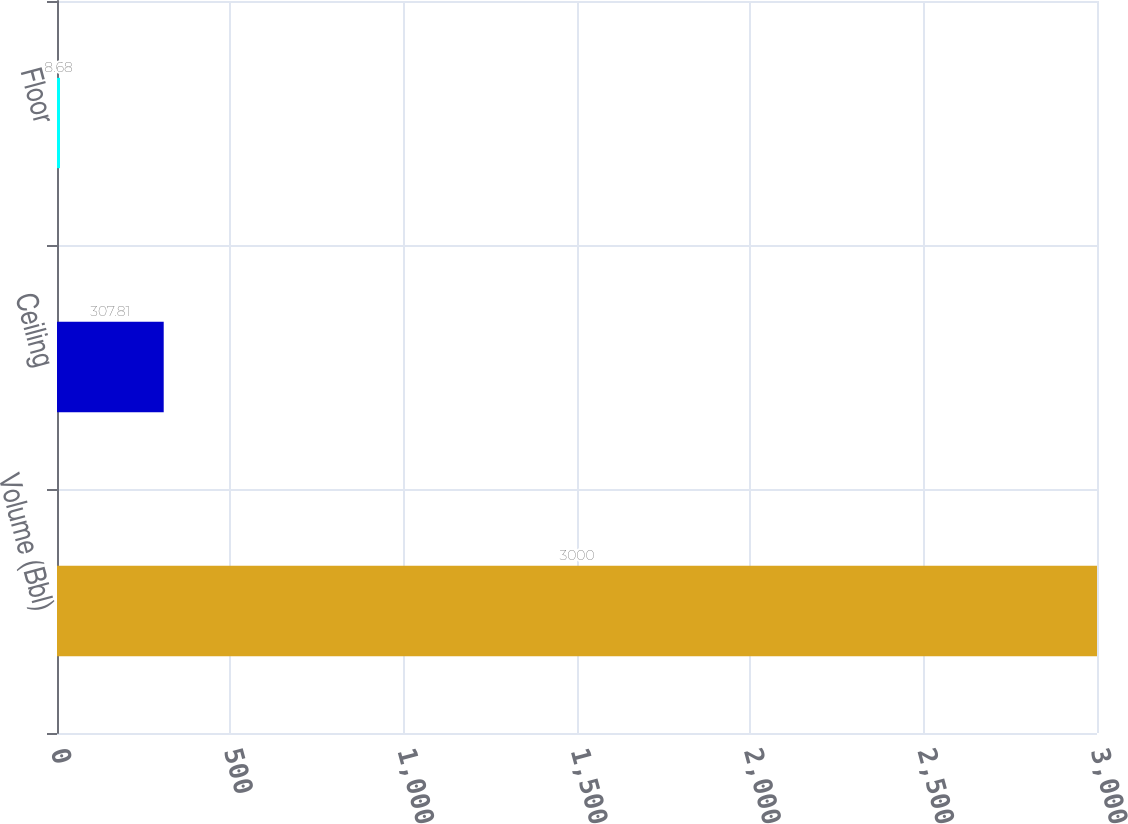Convert chart. <chart><loc_0><loc_0><loc_500><loc_500><bar_chart><fcel>Volume (Bbl)<fcel>Ceiling<fcel>Floor<nl><fcel>3000<fcel>307.81<fcel>8.68<nl></chart> 